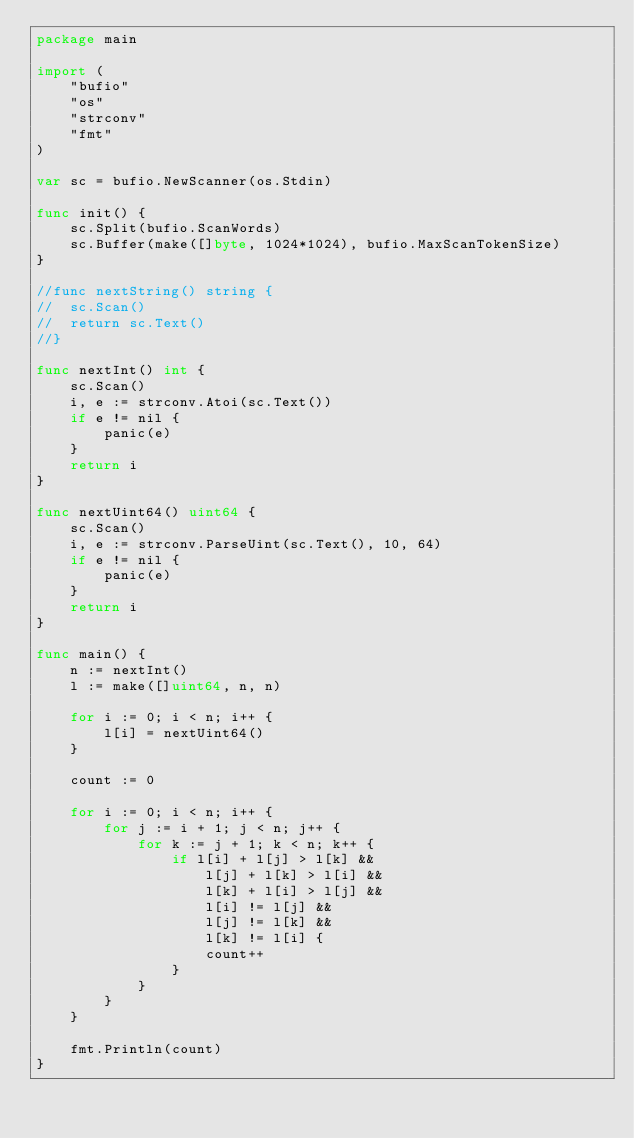Convert code to text. <code><loc_0><loc_0><loc_500><loc_500><_Go_>package main

import (
	"bufio"
	"os"
	"strconv"
	"fmt"
)

var sc = bufio.NewScanner(os.Stdin)

func init() {
	sc.Split(bufio.ScanWords)
	sc.Buffer(make([]byte, 1024*1024), bufio.MaxScanTokenSize)
}

//func nextString() string {
//	sc.Scan()
//	return sc.Text()
//}

func nextInt() int {
	sc.Scan()
	i, e := strconv.Atoi(sc.Text())
	if e != nil {
		panic(e)
	}
	return i
}

func nextUint64() uint64 {
	sc.Scan()
	i, e := strconv.ParseUint(sc.Text(), 10, 64)
	if e != nil {
		panic(e)
	}
	return i
}

func main() {
	n := nextInt()
	l := make([]uint64, n, n)

	for i := 0; i < n; i++ {
		l[i] = nextUint64()
	}

	count := 0

	for i := 0; i < n; i++ {
		for j := i + 1; j < n; j++ {
			for k := j + 1; k < n; k++ {
				if l[i] + l[j] > l[k] &&
					l[j] + l[k] > l[i] &&
					l[k] + l[i] > l[j] &&
					l[i] != l[j] &&
					l[j] != l[k] &&
					l[k] != l[i] {
					count++
				}
			}
		}
	}

	fmt.Println(count)
}
</code> 